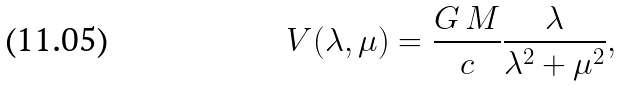Convert formula to latex. <formula><loc_0><loc_0><loc_500><loc_500>V ( \lambda , \mu ) = \frac { G \, M } { c } \frac { \lambda } { \lambda ^ { 2 } + \mu ^ { 2 } } ,</formula> 